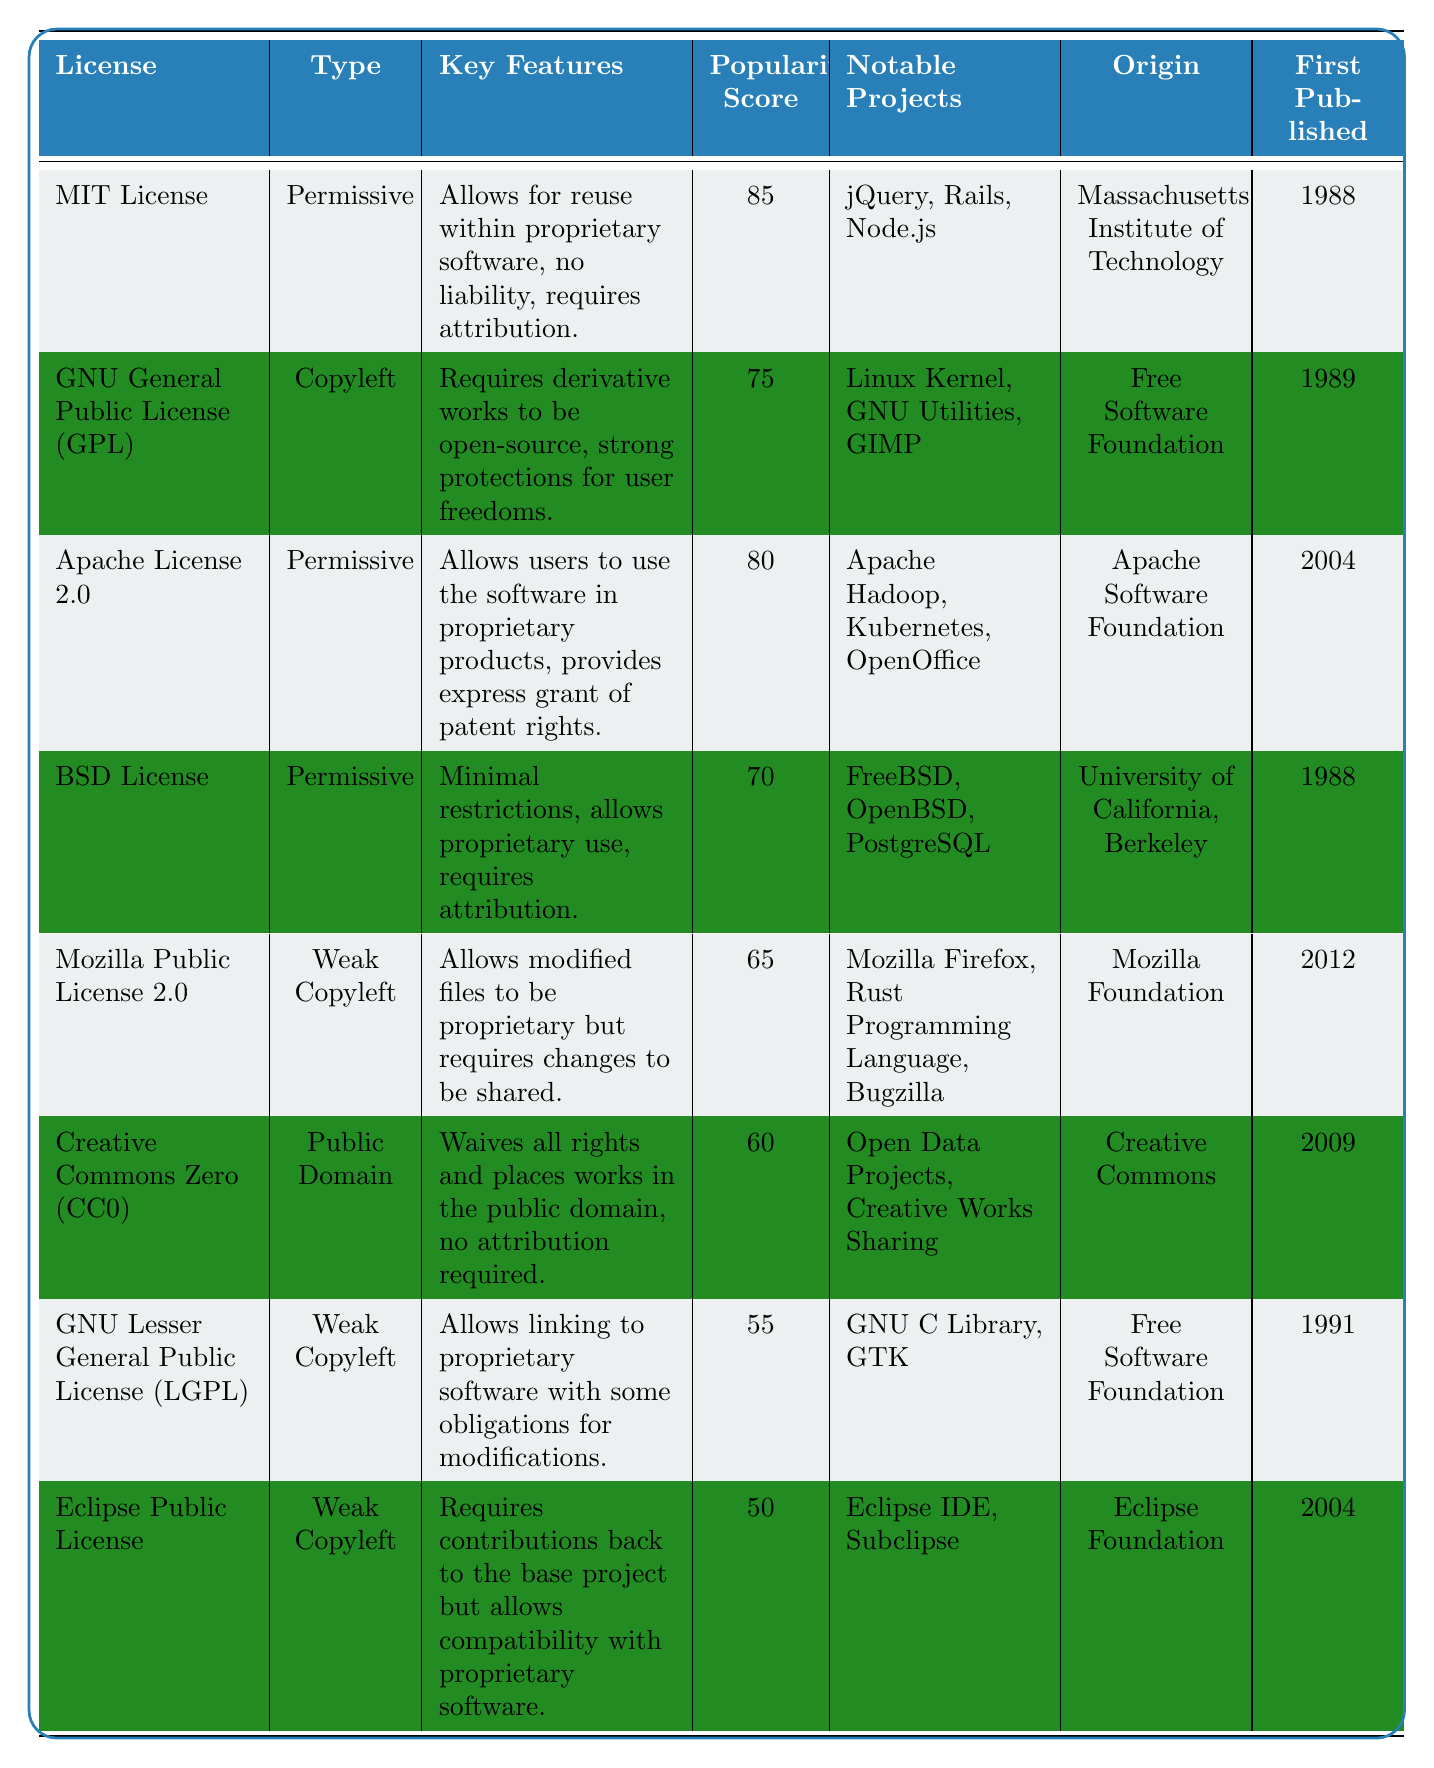What type of license is the Mozilla Public License 2.0? The type of license is located in the "Type" column corresponding to "Mozilla Public License 2.0," which shows it as "Weak Copyleft."
Answer: Weak Copyleft Which license has the highest popularity score? The "Popularity Score" column shows that the MIT License has the highest score of 85, compared to others in the table.
Answer: MIT License How many licenses are categorized as "Permissive"? Counting the licenses under the "Type" column, there are four that are categorized as "Permissive" (MIT, Apache, BSD).
Answer: Four What is the first published year of the GNU General Public License? The "First Published" column for "GNU General Public License (GPL)" shows the year as 1989.
Answer: 1989 Which license allows users to place works in the public domain? The "Key Features" column indicates that the Creative Commons Zero (CC0) license allows for waiving all rights and placing works in the public domain.
Answer: Creative Commons Zero (CC0) What is the average popularity score of Weak Copyleft licenses? There are three Weak Copyleft licenses (Mozilla Public License 2.0, GNU Lesser General Public License, Eclipse Public License) with scores of 65, 55, and 50. The average is (65 + 55 + 50) / 3 = 56.67.
Answer: 56.67 How many notable projects are listed for the BSD License? The "Notable Projects" column for "BSD License" lists three projects: FreeBSD, OpenBSD, and PostgreSQL.
Answer: Three Is the Apache License 2.0 older than the Mozilla Public License 2.0? Comparing the "First Published" years, Apache License 2.0 was published in 2004 and Mozilla Public License 2.0 in 2012, making Apache License older.
Answer: Yes What is the difference in popularity scores between the MIT License and the GNU General Public License? The popularity scores are 85 for MIT License and 75 for GNU GPL. Hence, the difference is 85 - 75 = 10.
Answer: 10 Which license has the least popularity score, and what is it? The lowest popularity score is in the Eclipse Public License, which scores 50.
Answer: Eclipse Public License, 50 